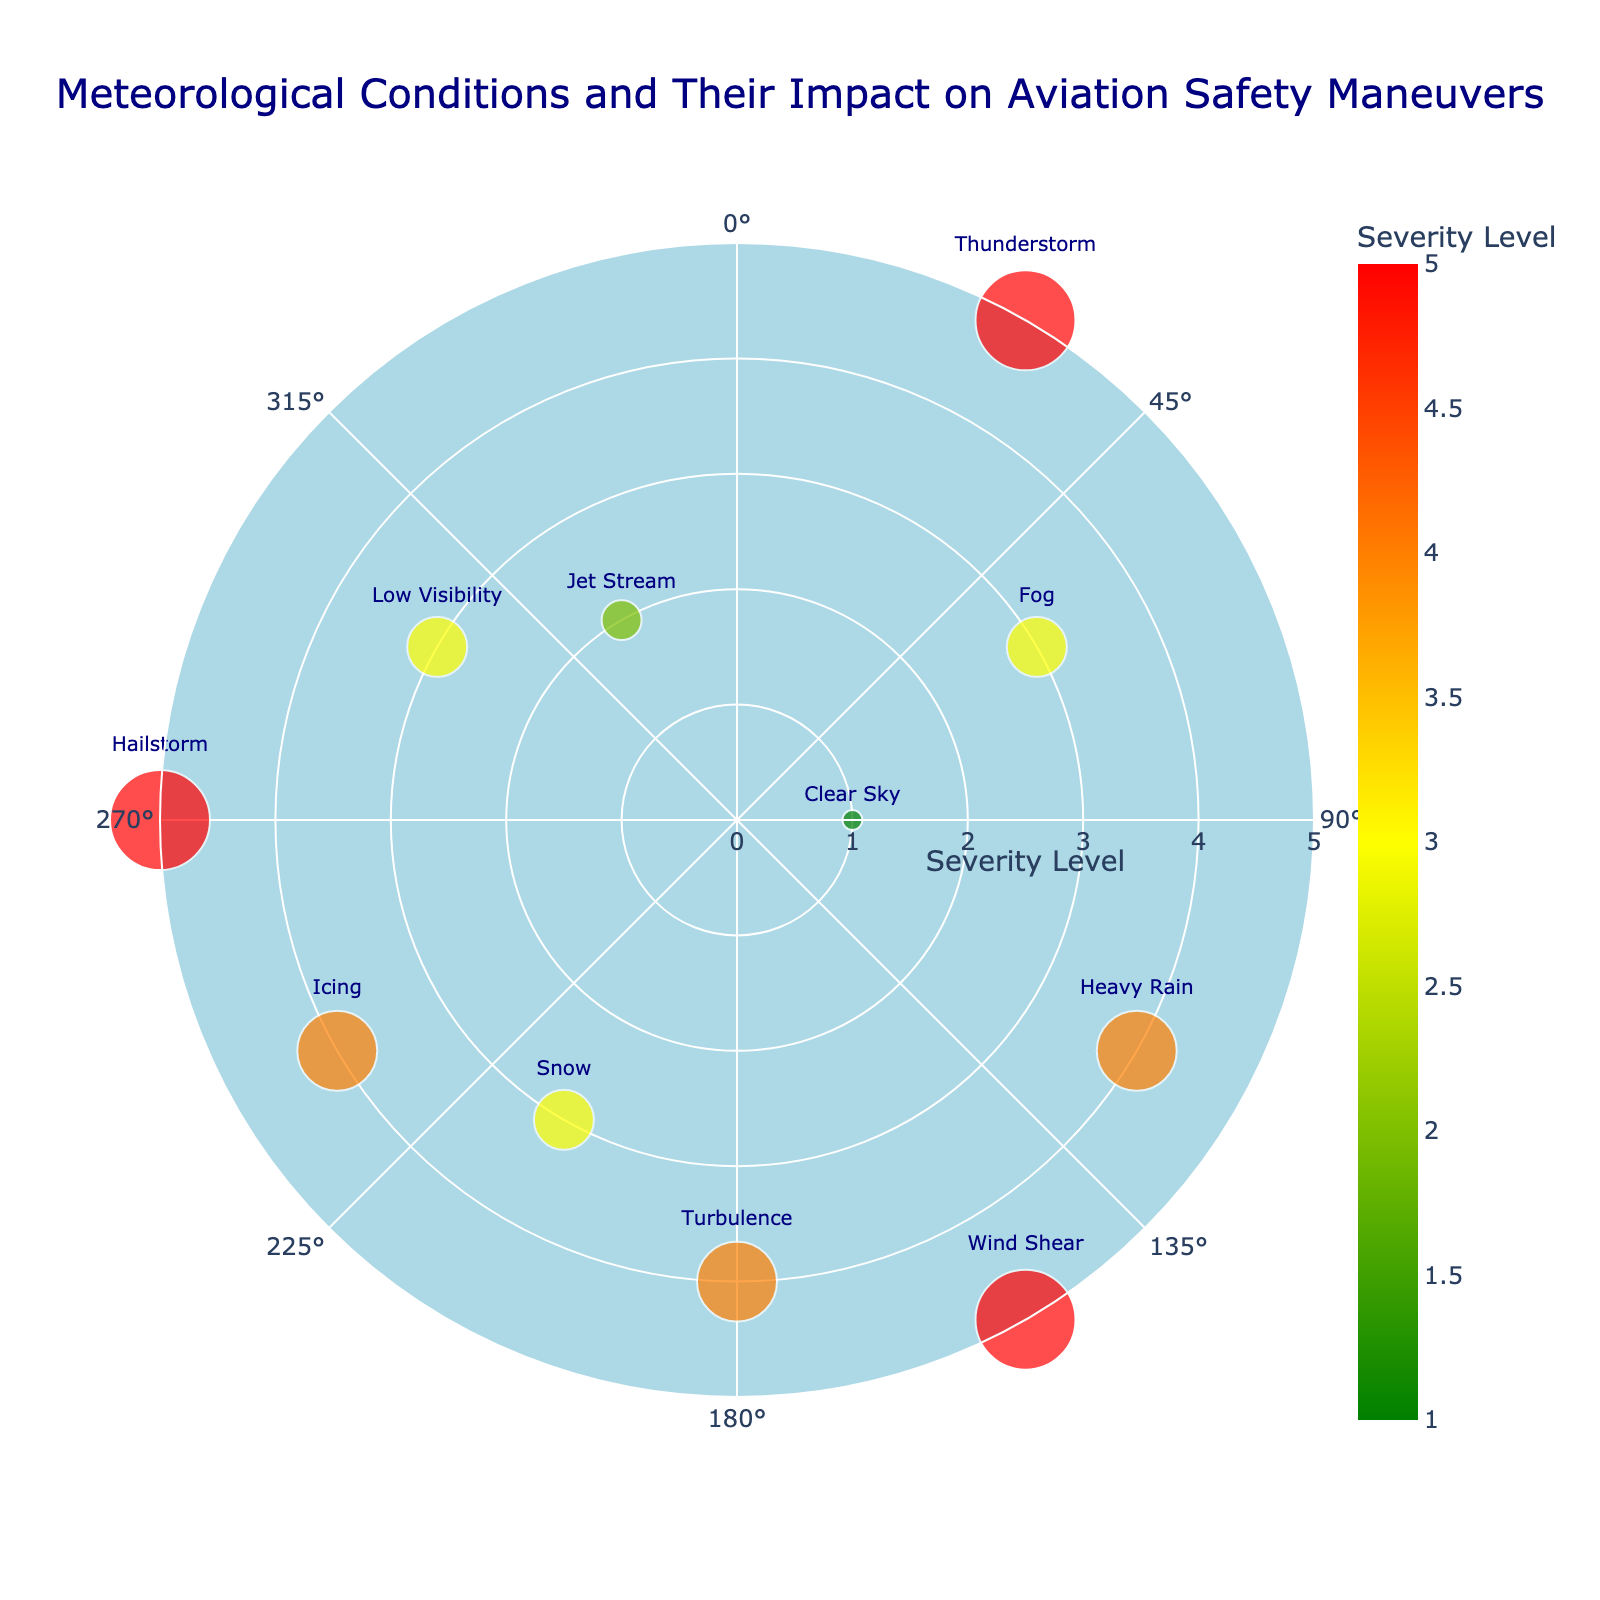What is the title of the chart? The title is centrally placed at the top of the chart, so by reading the text there, we can identify it.
Answer: Meteorological Conditions and Their Impact on Aviation Safety Maneuvers How many data points are shown in the chart? By counting the markers or points displayed on the chart, we can determine the number of data points presented. Each point represents a different meteorological condition.
Answer: 11 Which meteorological condition has the highest severity level? We look for the data point with the largest marker size or the highest numeric value next to it. Specifically, we can identify Thunderstorm, Wind Shear, and Hailstorm since they have a severity level of 5.
Answer: Thunderstorm, Wind Shear, Hailstorm What is the severity level of turbulence? By locating the text label "Turbulence" on the chart and observing the numeric value of the marker, we find the severity level.
Answer: 4 What are the meteorological conditions with a moderate impact? We look at the hover text labels that specifically mention "Moderate" as their impact and match those labels with their corresponding conditions.
Answer: Fog, Snow, Low Visibility, Jet Stream Which meteorological condition has the lowest severity level and what is it? Identifying the smallest marker on the chart or finding the numeric value '1' among the labels helps. By doing this, Clear Sky stands out with the severity level of 1.
Answer: Clear Sky, 1 What is the average severity level of all meteorological conditions combined? Sum the severity levels of all conditions (5+3+1+4+5+4+3+4+5+3+2) and divide by the number of conditions (11). (5+3+1+4+5+4+3+4+5+3+2) = 39; average = 39/11.
Answer: 3.54 Which condition at a 240-degree direction has a high impact? Locate the point at a 240-degree direction and check the hover text to see the impact level. The point labeled "Icing" has a high impact.
Answer: Icing Compare the severity levels of Thunderstorm and Heavy Rain. Which one is higher? Look at the markers labeled "Thunderstorm" and "Heavy Rain" and compare the numeric severity values. Both have severity levels, but Thunderstorm has a 5, and Heavy Rain has 4.
Answer: Thunderstorm What is the impact of the condition situated at a 60-degree direction? Find the point located at a 60-degree direction and observe the hover text to see the impact level. The point labeled "Fog" has a moderate impact.
Answer: Moderate 